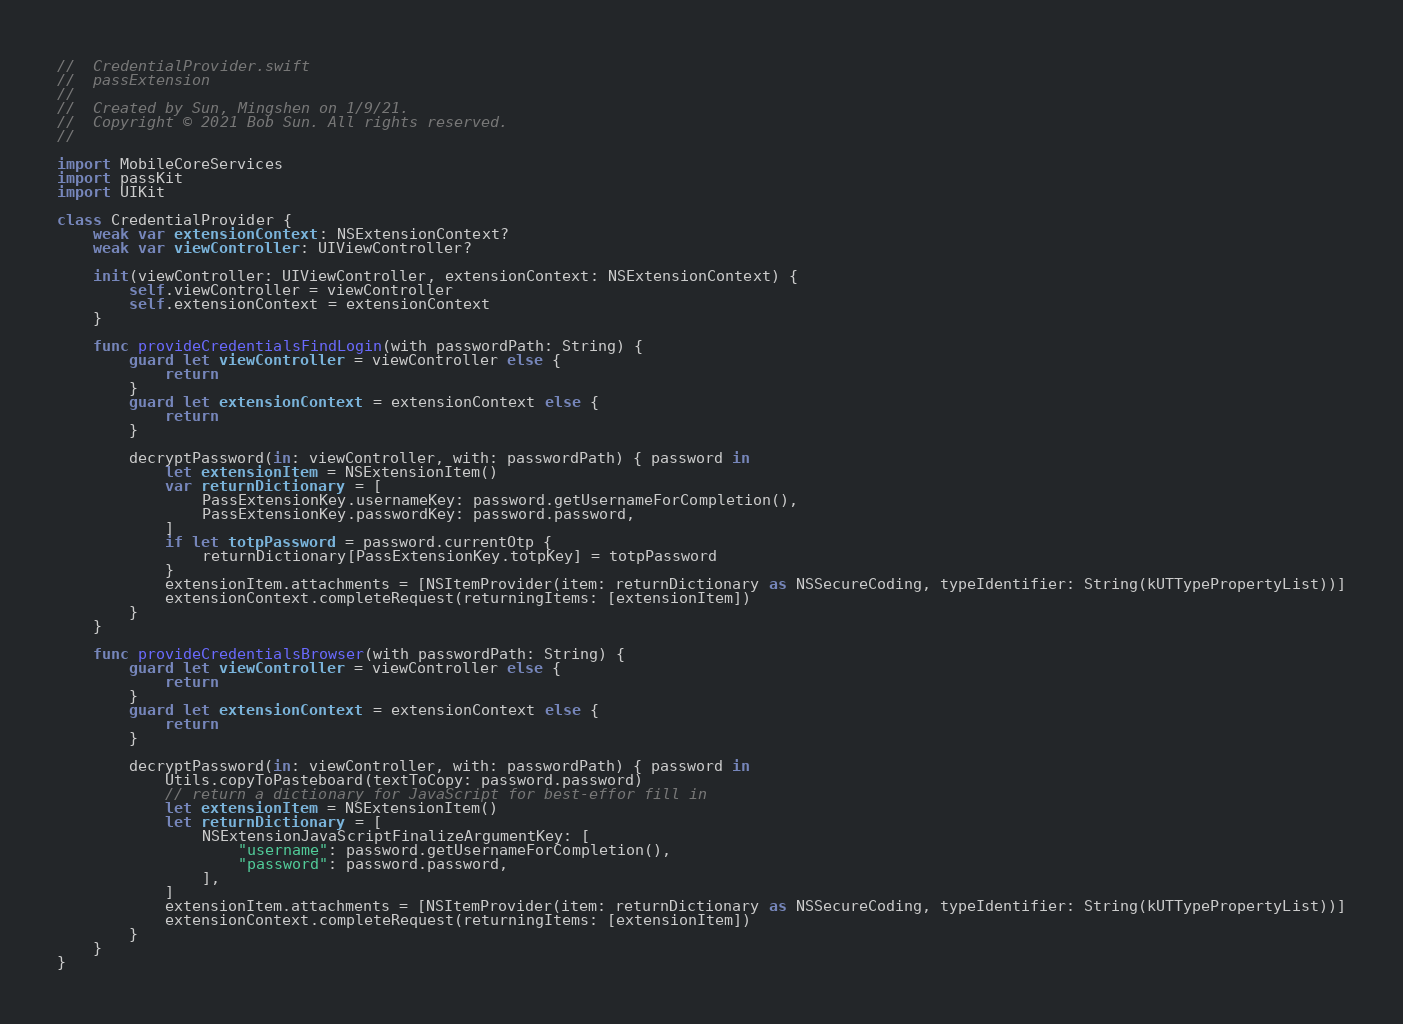Convert code to text. <code><loc_0><loc_0><loc_500><loc_500><_Swift_>//  CredentialProvider.swift
//  passExtension
//
//  Created by Sun, Mingshen on 1/9/21.
//  Copyright © 2021 Bob Sun. All rights reserved.
//

import MobileCoreServices
import passKit
import UIKit

class CredentialProvider {
    weak var extensionContext: NSExtensionContext?
    weak var viewController: UIViewController?

    init(viewController: UIViewController, extensionContext: NSExtensionContext) {
        self.viewController = viewController
        self.extensionContext = extensionContext
    }

    func provideCredentialsFindLogin(with passwordPath: String) {
        guard let viewController = viewController else {
            return
        }
        guard let extensionContext = extensionContext else {
            return
        }

        decryptPassword(in: viewController, with: passwordPath) { password in
            let extensionItem = NSExtensionItem()
            var returnDictionary = [
                PassExtensionKey.usernameKey: password.getUsernameForCompletion(),
                PassExtensionKey.passwordKey: password.password,
            ]
            if let totpPassword = password.currentOtp {
                returnDictionary[PassExtensionKey.totpKey] = totpPassword
            }
            extensionItem.attachments = [NSItemProvider(item: returnDictionary as NSSecureCoding, typeIdentifier: String(kUTTypePropertyList))]
            extensionContext.completeRequest(returningItems: [extensionItem])
        }
    }

    func provideCredentialsBrowser(with passwordPath: String) {
        guard let viewController = viewController else {
            return
        }
        guard let extensionContext = extensionContext else {
            return
        }

        decryptPassword(in: viewController, with: passwordPath) { password in
            Utils.copyToPasteboard(textToCopy: password.password)
            // return a dictionary for JavaScript for best-effor fill in
            let extensionItem = NSExtensionItem()
            let returnDictionary = [
                NSExtensionJavaScriptFinalizeArgumentKey: [
                    "username": password.getUsernameForCompletion(),
                    "password": password.password,
                ],
            ]
            extensionItem.attachments = [NSItemProvider(item: returnDictionary as NSSecureCoding, typeIdentifier: String(kUTTypePropertyList))]
            extensionContext.completeRequest(returningItems: [extensionItem])
        }
    }
}
</code> 